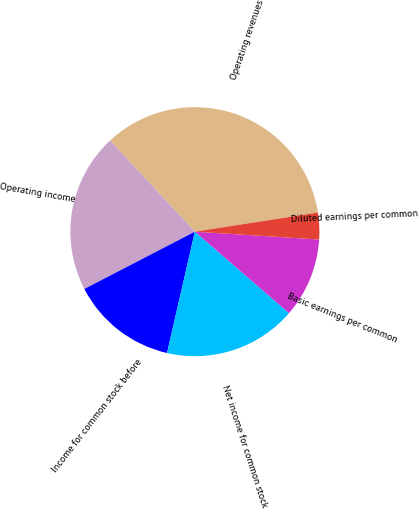Convert chart. <chart><loc_0><loc_0><loc_500><loc_500><pie_chart><fcel>Operating revenues<fcel>Operating income<fcel>Income for common stock before<fcel>Net income for common stock<fcel>Basic earnings per common<fcel>Diluted earnings per common<nl><fcel>34.47%<fcel>20.69%<fcel>13.8%<fcel>17.24%<fcel>10.35%<fcel>3.46%<nl></chart> 